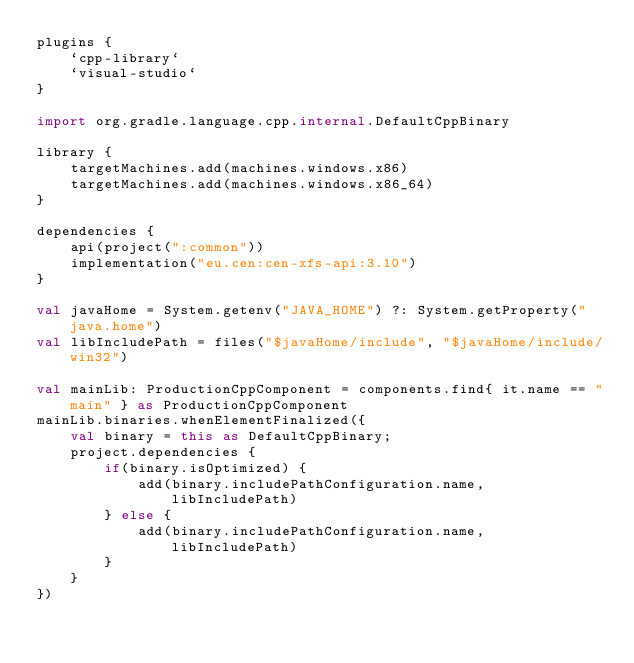<code> <loc_0><loc_0><loc_500><loc_500><_Kotlin_>plugins {
    `cpp-library`
    `visual-studio`
}

import org.gradle.language.cpp.internal.DefaultCppBinary

library {
    targetMachines.add(machines.windows.x86)
    targetMachines.add(machines.windows.x86_64)
}

dependencies {
    api(project(":common"))
    implementation("eu.cen:cen-xfs-api:3.10")
}

val javaHome = System.getenv("JAVA_HOME") ?: System.getProperty("java.home")
val libIncludePath = files("$javaHome/include", "$javaHome/include/win32")

val mainLib: ProductionCppComponent = components.find{ it.name == "main" } as ProductionCppComponent
mainLib.binaries.whenElementFinalized({
    val binary = this as DefaultCppBinary;
    project.dependencies {
        if(binary.isOptimized) {
            add(binary.includePathConfiguration.name, libIncludePath)
        } else {
            add(binary.includePathConfiguration.name, libIncludePath)
        }
    }
})
</code> 